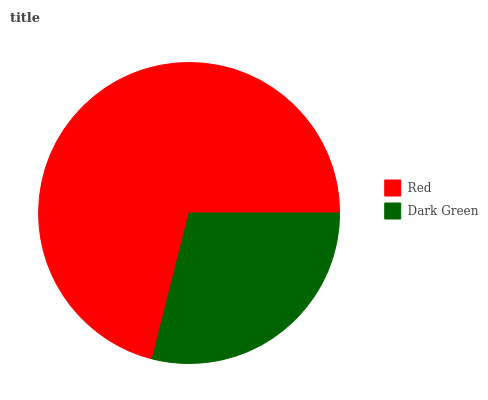Is Dark Green the minimum?
Answer yes or no. Yes. Is Red the maximum?
Answer yes or no. Yes. Is Dark Green the maximum?
Answer yes or no. No. Is Red greater than Dark Green?
Answer yes or no. Yes. Is Dark Green less than Red?
Answer yes or no. Yes. Is Dark Green greater than Red?
Answer yes or no. No. Is Red less than Dark Green?
Answer yes or no. No. Is Red the high median?
Answer yes or no. Yes. Is Dark Green the low median?
Answer yes or no. Yes. Is Dark Green the high median?
Answer yes or no. No. Is Red the low median?
Answer yes or no. No. 